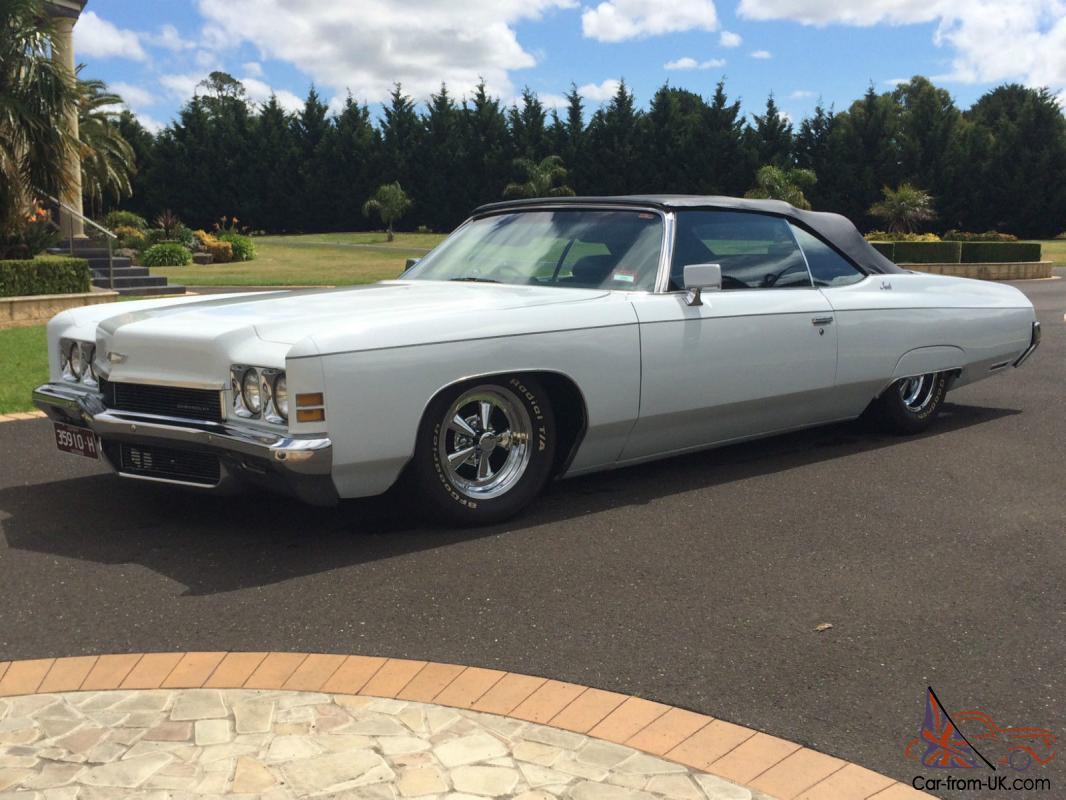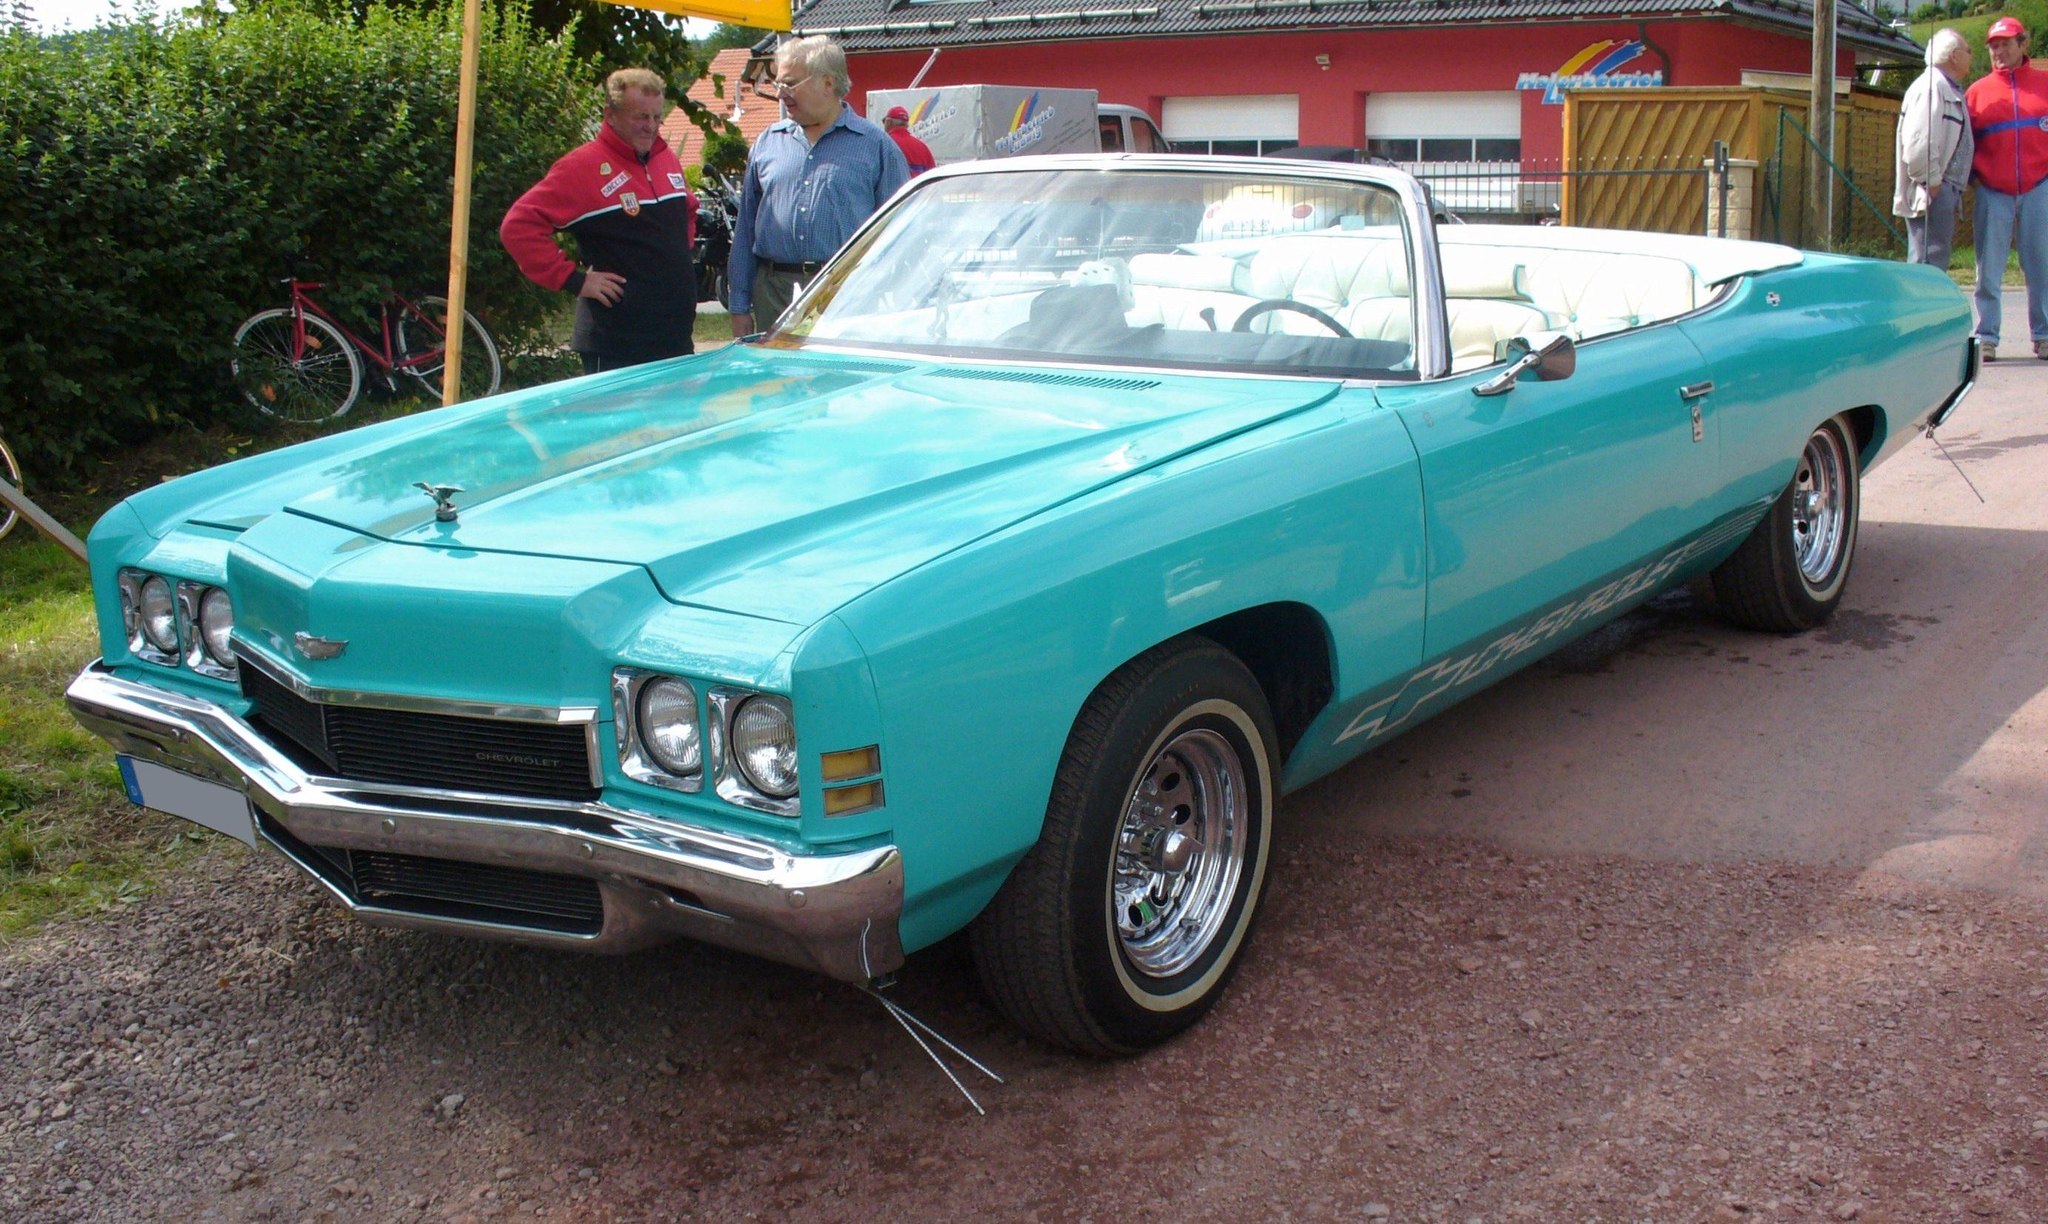The first image is the image on the left, the second image is the image on the right. Assess this claim about the two images: "One or more of the cars shown are turned to the right.". Correct or not? Answer yes or no. No. The first image is the image on the left, the second image is the image on the right. Considering the images on both sides, is "An image shows a convertible car covered with a dark top." valid? Answer yes or no. Yes. 